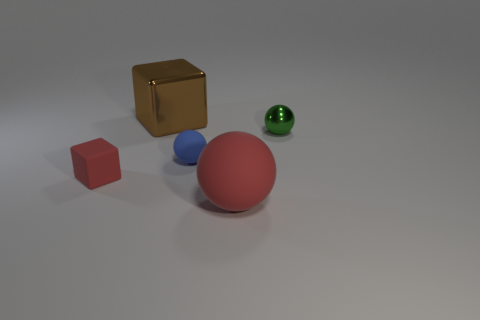What materials appear to make up the objects in the image? The objects in the image seem to be made from different materials. The large red object and the small blue object seem to be glossy and might be made of a plastic or polished material. The gold cube looks metallic, suggesting it might be made of metal. 